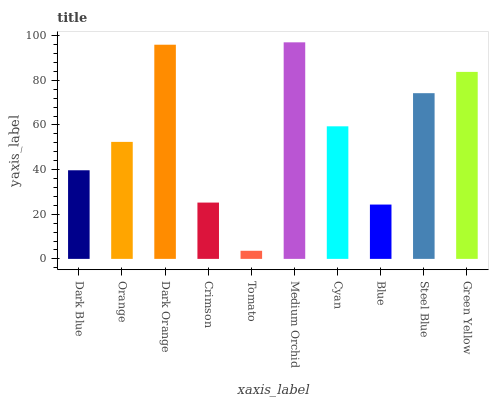Is Tomato the minimum?
Answer yes or no. Yes. Is Medium Orchid the maximum?
Answer yes or no. Yes. Is Orange the minimum?
Answer yes or no. No. Is Orange the maximum?
Answer yes or no. No. Is Orange greater than Dark Blue?
Answer yes or no. Yes. Is Dark Blue less than Orange?
Answer yes or no. Yes. Is Dark Blue greater than Orange?
Answer yes or no. No. Is Orange less than Dark Blue?
Answer yes or no. No. Is Cyan the high median?
Answer yes or no. Yes. Is Orange the low median?
Answer yes or no. Yes. Is Orange the high median?
Answer yes or no. No. Is Crimson the low median?
Answer yes or no. No. 